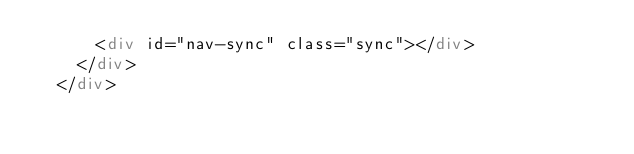Convert code to text. <code><loc_0><loc_0><loc_500><loc_500><_HTML_>      <div id="nav-sync" class="sync"></div>
    </div>
  </div></code> 